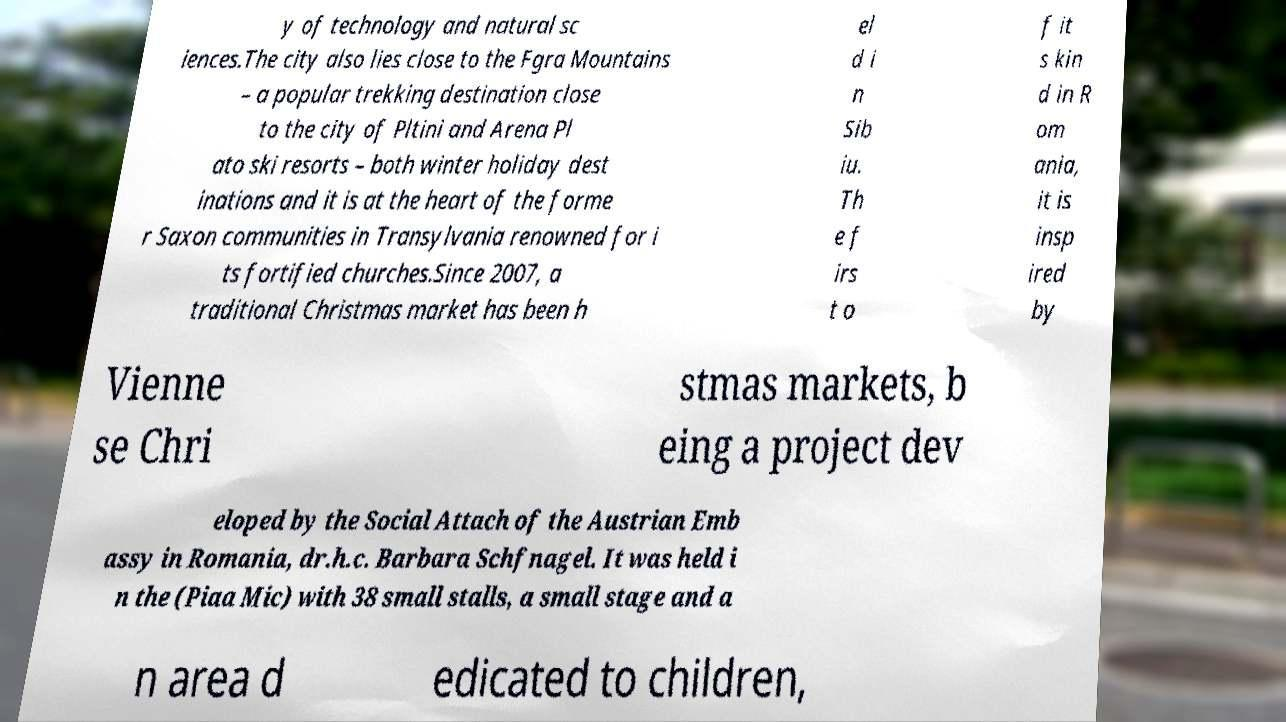Please read and relay the text visible in this image. What does it say? y of technology and natural sc iences.The city also lies close to the Fgra Mountains – a popular trekking destination close to the city of Pltini and Arena Pl ato ski resorts – both winter holiday dest inations and it is at the heart of the forme r Saxon communities in Transylvania renowned for i ts fortified churches.Since 2007, a traditional Christmas market has been h el d i n Sib iu. Th e f irs t o f it s kin d in R om ania, it is insp ired by Vienne se Chri stmas markets, b eing a project dev eloped by the Social Attach of the Austrian Emb assy in Romania, dr.h.c. Barbara Schfnagel. It was held i n the (Piaa Mic) with 38 small stalls, a small stage and a n area d edicated to children, 